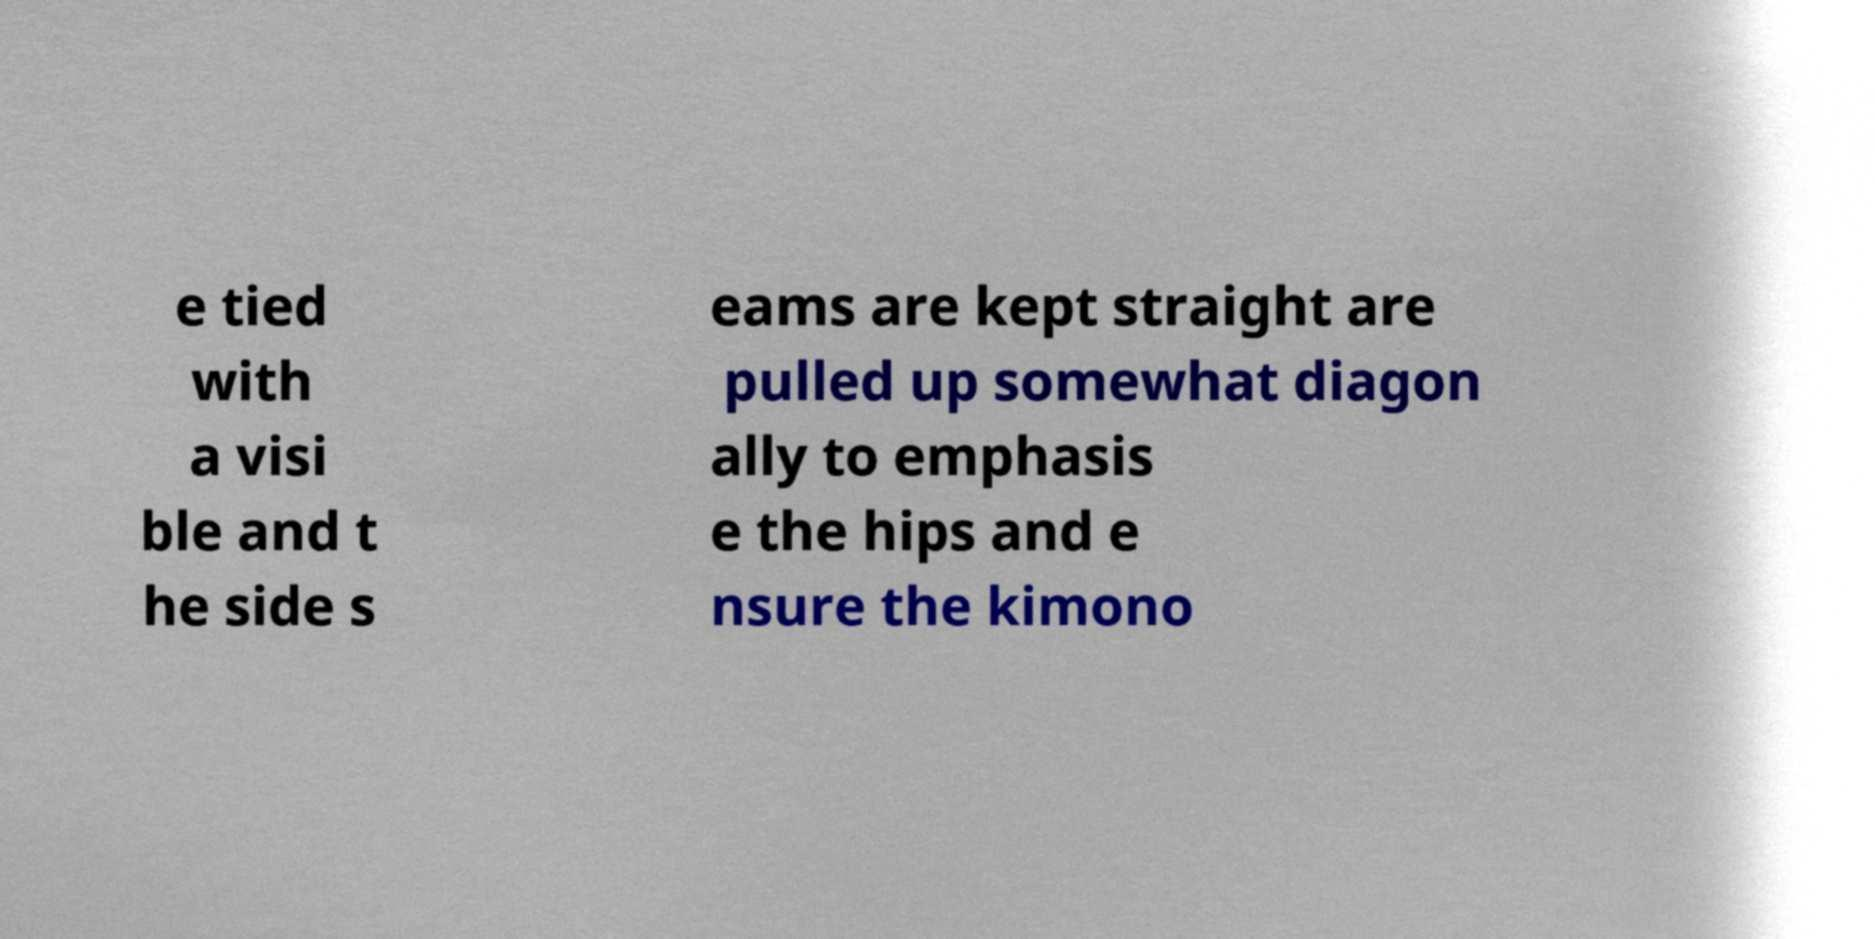Can you accurately transcribe the text from the provided image for me? e tied with a visi ble and t he side s eams are kept straight are pulled up somewhat diagon ally to emphasis e the hips and e nsure the kimono 